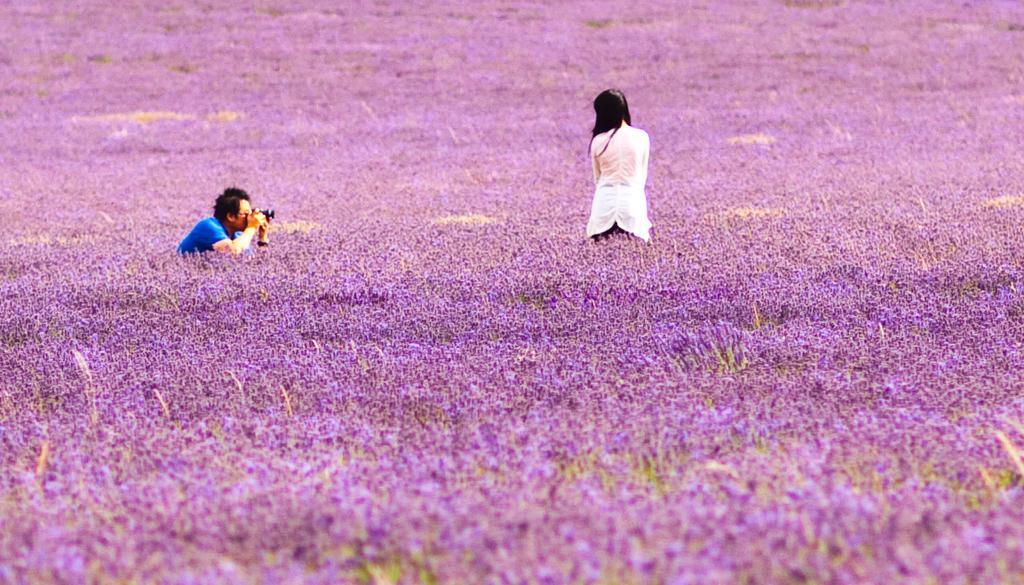Describe this image in one or two sentences. In this image we can see two persons standing. One person is holding a camera in his hand. In the background, we can see the flowers. 